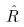<formula> <loc_0><loc_0><loc_500><loc_500>\hat { R }</formula> 